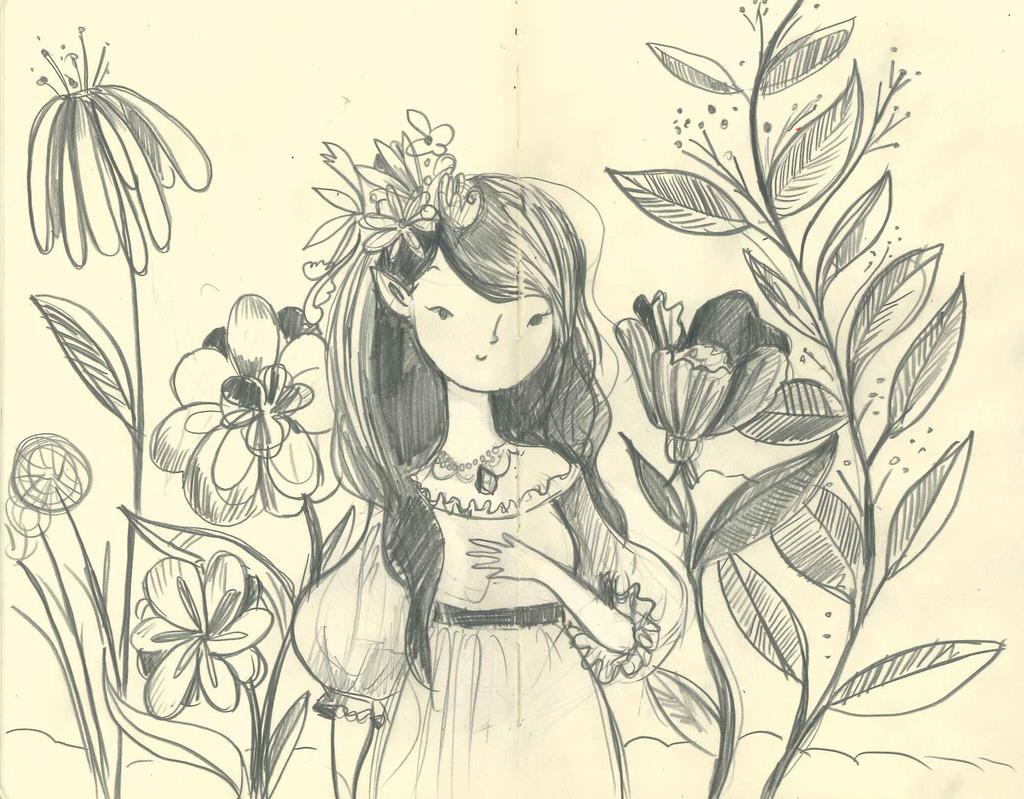What is depicted in the image? The image contains sketches of a woman, plants, and flowers. Can you describe the woman in the sketch? The sketch of the woman is the main subject in the image, but no specific details about her appearance are provided. What type of plants are depicted in the sketch? The sketch of plants is another subject in the image, but no specific details about the plants are provided. What type of flowers are depicted in the sketch? The sketch of flowers is another subject in the image, but no specific details about the flowers are provided. What type of nerve can be seen in the sketch of the woman? There is no mention of a nerve in the image, as it contains sketches of a woman, plants, and flowers. Can you describe the squirrel in the sketch of the plants? There is no squirrel present in the image; it contains sketches of a woman, plants, and flowers. 